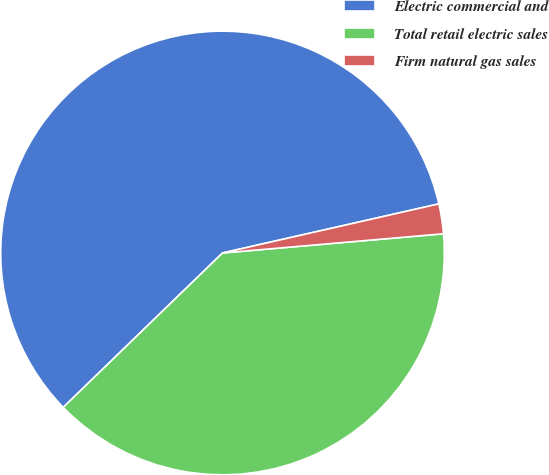<chart> <loc_0><loc_0><loc_500><loc_500><pie_chart><fcel>Electric commercial and<fcel>Total retail electric sales<fcel>Firm natural gas sales<nl><fcel>58.7%<fcel>39.13%<fcel>2.17%<nl></chart> 